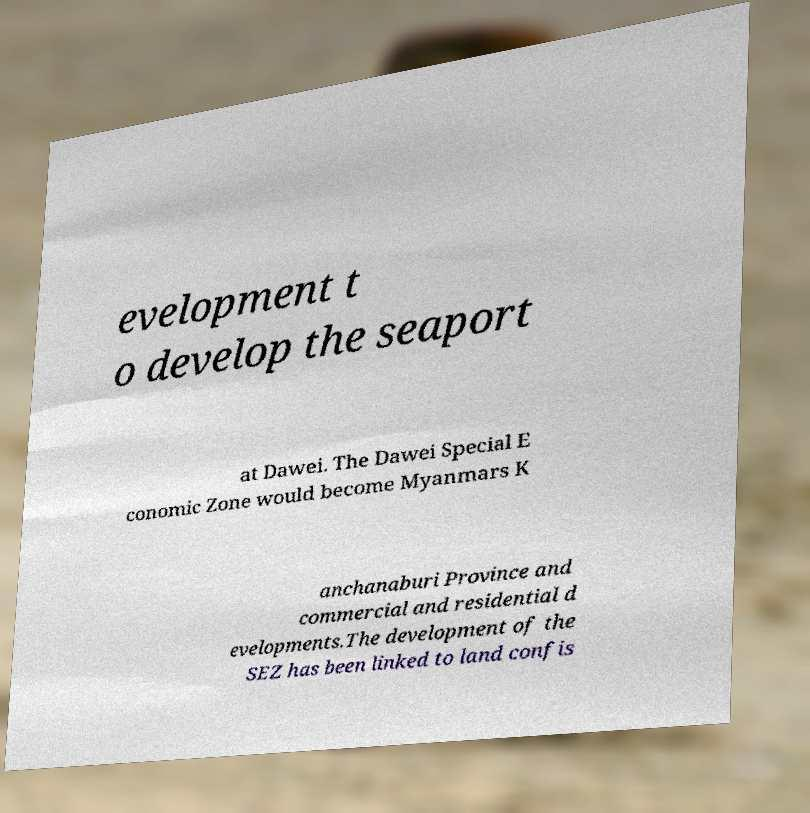What messages or text are displayed in this image? I need them in a readable, typed format. evelopment t o develop the seaport at Dawei. The Dawei Special E conomic Zone would become Myanmars K anchanaburi Province and commercial and residential d evelopments.The development of the SEZ has been linked to land confis 